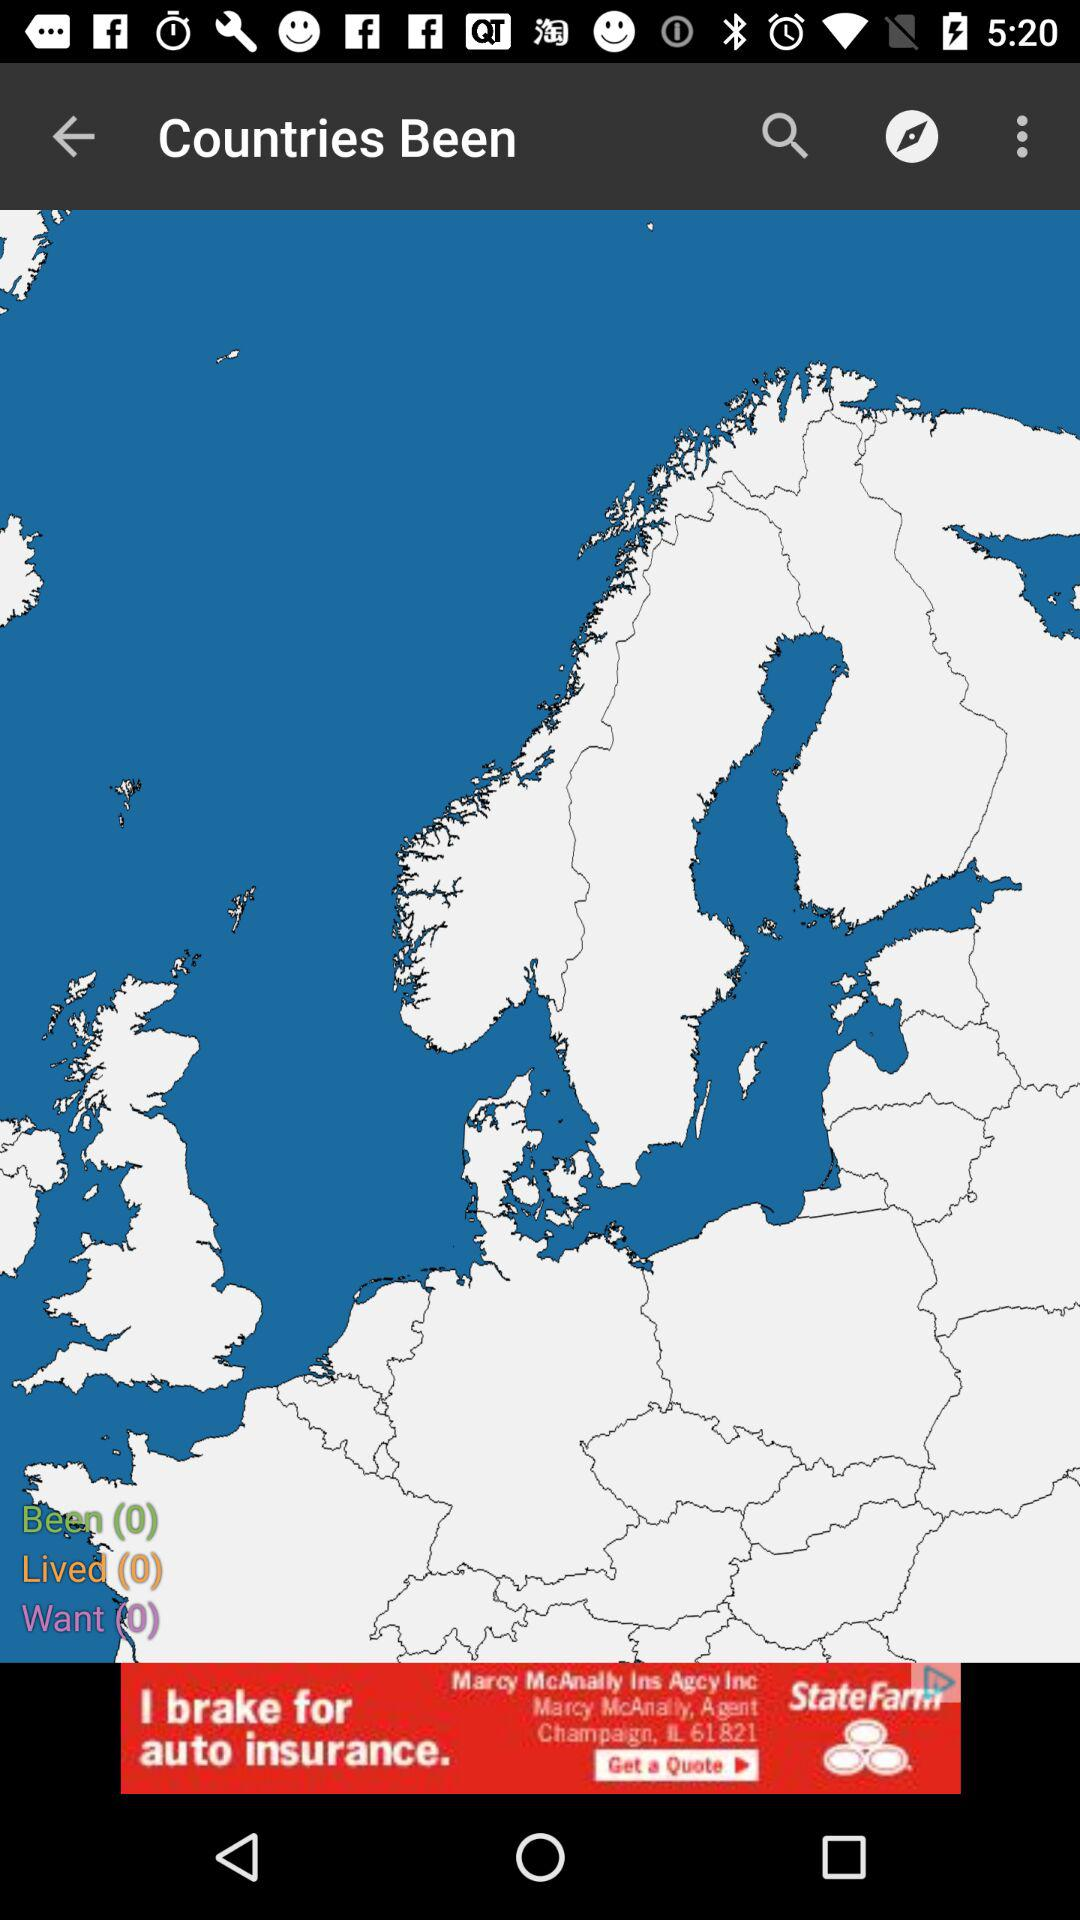How many countries have I been to? You have been to 0 countries. 